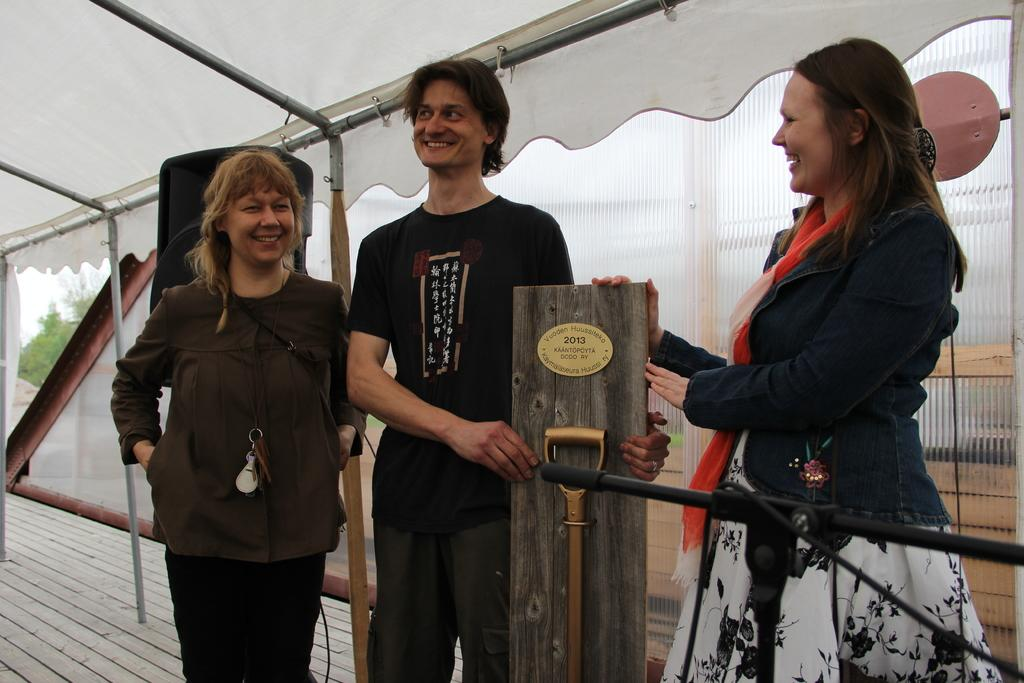How many people are in the image? There are three people in the image: a man, a lady, and another lady. What are the man and lady holding in the image? The man and lady are standing and holding a wood board. What can be seen in the background of the image? There is a tent and a stand visible in the background of the image. What type of pain is the man experiencing in the image? There is no indication in the image that the man is experiencing any pain. How does the lady wash the wood board in the image? There is no washing activity depicted in the image; the man and lady are simply holding the wood board. 